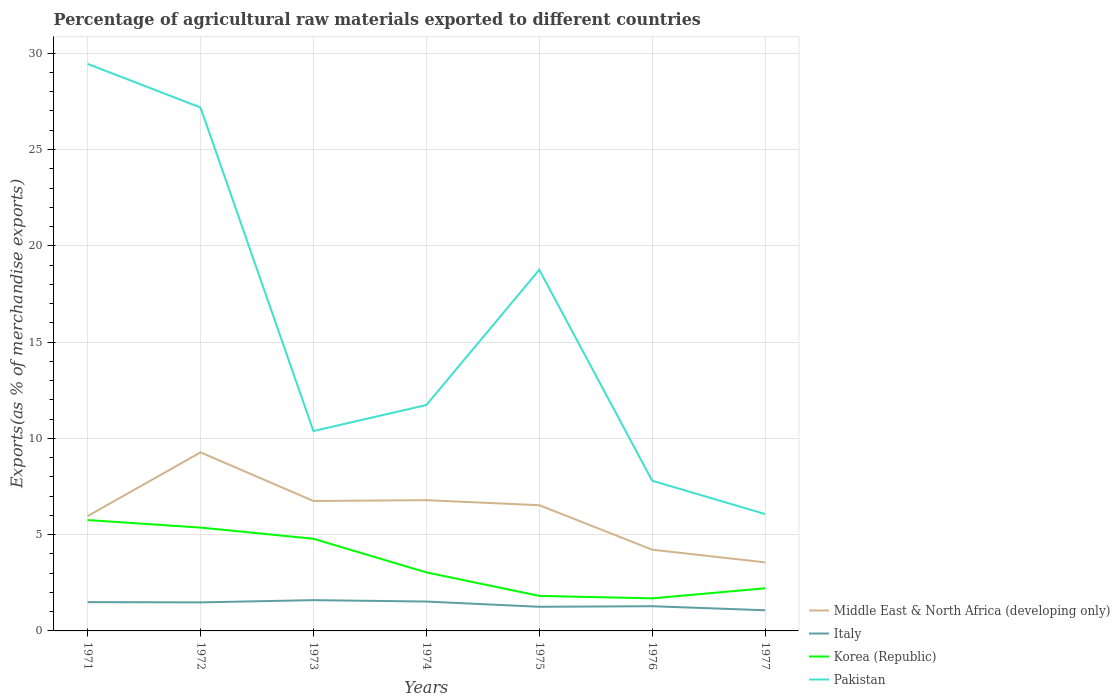How many different coloured lines are there?
Your response must be concise. 4. Is the number of lines equal to the number of legend labels?
Offer a terse response. Yes. Across all years, what is the maximum percentage of exports to different countries in Korea (Republic)?
Offer a very short reply. 1.69. In which year was the percentage of exports to different countries in Italy maximum?
Provide a succinct answer. 1977. What is the total percentage of exports to different countries in Pakistan in the graph?
Your answer should be very brief. 5.66. What is the difference between the highest and the second highest percentage of exports to different countries in Pakistan?
Your response must be concise. 23.38. What is the difference between the highest and the lowest percentage of exports to different countries in Italy?
Make the answer very short. 4. Is the percentage of exports to different countries in Italy strictly greater than the percentage of exports to different countries in Pakistan over the years?
Give a very brief answer. Yes. How many lines are there?
Keep it short and to the point. 4. Are the values on the major ticks of Y-axis written in scientific E-notation?
Make the answer very short. No. Does the graph contain any zero values?
Provide a short and direct response. No. Does the graph contain grids?
Your answer should be very brief. Yes. How are the legend labels stacked?
Your response must be concise. Vertical. What is the title of the graph?
Make the answer very short. Percentage of agricultural raw materials exported to different countries. Does "Chile" appear as one of the legend labels in the graph?
Provide a short and direct response. No. What is the label or title of the X-axis?
Your answer should be very brief. Years. What is the label or title of the Y-axis?
Your answer should be very brief. Exports(as % of merchandise exports). What is the Exports(as % of merchandise exports) of Middle East & North Africa (developing only) in 1971?
Your response must be concise. 5.96. What is the Exports(as % of merchandise exports) of Italy in 1971?
Offer a very short reply. 1.49. What is the Exports(as % of merchandise exports) of Korea (Republic) in 1971?
Provide a short and direct response. 5.76. What is the Exports(as % of merchandise exports) in Pakistan in 1971?
Provide a succinct answer. 29.45. What is the Exports(as % of merchandise exports) in Middle East & North Africa (developing only) in 1972?
Give a very brief answer. 9.27. What is the Exports(as % of merchandise exports) in Italy in 1972?
Your response must be concise. 1.48. What is the Exports(as % of merchandise exports) of Korea (Republic) in 1972?
Keep it short and to the point. 5.37. What is the Exports(as % of merchandise exports) of Pakistan in 1972?
Offer a very short reply. 27.18. What is the Exports(as % of merchandise exports) of Middle East & North Africa (developing only) in 1973?
Your answer should be compact. 6.75. What is the Exports(as % of merchandise exports) of Italy in 1973?
Provide a short and direct response. 1.6. What is the Exports(as % of merchandise exports) of Korea (Republic) in 1973?
Your response must be concise. 4.79. What is the Exports(as % of merchandise exports) in Pakistan in 1973?
Your response must be concise. 10.38. What is the Exports(as % of merchandise exports) of Middle East & North Africa (developing only) in 1974?
Make the answer very short. 6.79. What is the Exports(as % of merchandise exports) of Italy in 1974?
Offer a very short reply. 1.53. What is the Exports(as % of merchandise exports) in Korea (Republic) in 1974?
Provide a short and direct response. 3.04. What is the Exports(as % of merchandise exports) in Pakistan in 1974?
Keep it short and to the point. 11.73. What is the Exports(as % of merchandise exports) of Middle East & North Africa (developing only) in 1975?
Offer a terse response. 6.53. What is the Exports(as % of merchandise exports) of Italy in 1975?
Make the answer very short. 1.25. What is the Exports(as % of merchandise exports) of Korea (Republic) in 1975?
Keep it short and to the point. 1.82. What is the Exports(as % of merchandise exports) of Pakistan in 1975?
Offer a terse response. 18.75. What is the Exports(as % of merchandise exports) of Middle East & North Africa (developing only) in 1976?
Offer a terse response. 4.22. What is the Exports(as % of merchandise exports) of Italy in 1976?
Offer a terse response. 1.28. What is the Exports(as % of merchandise exports) in Korea (Republic) in 1976?
Give a very brief answer. 1.69. What is the Exports(as % of merchandise exports) of Pakistan in 1976?
Provide a succinct answer. 7.8. What is the Exports(as % of merchandise exports) of Middle East & North Africa (developing only) in 1977?
Offer a terse response. 3.56. What is the Exports(as % of merchandise exports) of Italy in 1977?
Offer a very short reply. 1.07. What is the Exports(as % of merchandise exports) in Korea (Republic) in 1977?
Offer a very short reply. 2.21. What is the Exports(as % of merchandise exports) in Pakistan in 1977?
Keep it short and to the point. 6.07. Across all years, what is the maximum Exports(as % of merchandise exports) in Middle East & North Africa (developing only)?
Provide a short and direct response. 9.27. Across all years, what is the maximum Exports(as % of merchandise exports) of Italy?
Make the answer very short. 1.6. Across all years, what is the maximum Exports(as % of merchandise exports) in Korea (Republic)?
Make the answer very short. 5.76. Across all years, what is the maximum Exports(as % of merchandise exports) in Pakistan?
Give a very brief answer. 29.45. Across all years, what is the minimum Exports(as % of merchandise exports) of Middle East & North Africa (developing only)?
Give a very brief answer. 3.56. Across all years, what is the minimum Exports(as % of merchandise exports) in Italy?
Provide a short and direct response. 1.07. Across all years, what is the minimum Exports(as % of merchandise exports) of Korea (Republic)?
Make the answer very short. 1.69. Across all years, what is the minimum Exports(as % of merchandise exports) in Pakistan?
Make the answer very short. 6.07. What is the total Exports(as % of merchandise exports) of Middle East & North Africa (developing only) in the graph?
Ensure brevity in your answer.  43.08. What is the total Exports(as % of merchandise exports) of Italy in the graph?
Provide a succinct answer. 9.71. What is the total Exports(as % of merchandise exports) of Korea (Republic) in the graph?
Your answer should be compact. 24.68. What is the total Exports(as % of merchandise exports) of Pakistan in the graph?
Give a very brief answer. 111.36. What is the difference between the Exports(as % of merchandise exports) in Middle East & North Africa (developing only) in 1971 and that in 1972?
Offer a terse response. -3.31. What is the difference between the Exports(as % of merchandise exports) of Italy in 1971 and that in 1972?
Your answer should be compact. 0.01. What is the difference between the Exports(as % of merchandise exports) in Korea (Republic) in 1971 and that in 1972?
Your answer should be compact. 0.39. What is the difference between the Exports(as % of merchandise exports) in Pakistan in 1971 and that in 1972?
Give a very brief answer. 2.26. What is the difference between the Exports(as % of merchandise exports) in Middle East & North Africa (developing only) in 1971 and that in 1973?
Offer a very short reply. -0.79. What is the difference between the Exports(as % of merchandise exports) of Italy in 1971 and that in 1973?
Your response must be concise. -0.1. What is the difference between the Exports(as % of merchandise exports) of Korea (Republic) in 1971 and that in 1973?
Provide a succinct answer. 0.97. What is the difference between the Exports(as % of merchandise exports) of Pakistan in 1971 and that in 1973?
Keep it short and to the point. 19.07. What is the difference between the Exports(as % of merchandise exports) in Middle East & North Africa (developing only) in 1971 and that in 1974?
Give a very brief answer. -0.83. What is the difference between the Exports(as % of merchandise exports) in Italy in 1971 and that in 1974?
Your response must be concise. -0.03. What is the difference between the Exports(as % of merchandise exports) in Korea (Republic) in 1971 and that in 1974?
Provide a short and direct response. 2.72. What is the difference between the Exports(as % of merchandise exports) of Pakistan in 1971 and that in 1974?
Your answer should be very brief. 17.72. What is the difference between the Exports(as % of merchandise exports) of Middle East & North Africa (developing only) in 1971 and that in 1975?
Give a very brief answer. -0.57. What is the difference between the Exports(as % of merchandise exports) in Italy in 1971 and that in 1975?
Your answer should be very brief. 0.24. What is the difference between the Exports(as % of merchandise exports) in Korea (Republic) in 1971 and that in 1975?
Give a very brief answer. 3.94. What is the difference between the Exports(as % of merchandise exports) in Pakistan in 1971 and that in 1975?
Offer a very short reply. 10.69. What is the difference between the Exports(as % of merchandise exports) of Middle East & North Africa (developing only) in 1971 and that in 1976?
Keep it short and to the point. 1.74. What is the difference between the Exports(as % of merchandise exports) in Italy in 1971 and that in 1976?
Provide a succinct answer. 0.21. What is the difference between the Exports(as % of merchandise exports) in Korea (Republic) in 1971 and that in 1976?
Your response must be concise. 4.07. What is the difference between the Exports(as % of merchandise exports) in Pakistan in 1971 and that in 1976?
Ensure brevity in your answer.  21.64. What is the difference between the Exports(as % of merchandise exports) in Middle East & North Africa (developing only) in 1971 and that in 1977?
Make the answer very short. 2.4. What is the difference between the Exports(as % of merchandise exports) in Italy in 1971 and that in 1977?
Keep it short and to the point. 0.42. What is the difference between the Exports(as % of merchandise exports) in Korea (Republic) in 1971 and that in 1977?
Your answer should be compact. 3.54. What is the difference between the Exports(as % of merchandise exports) in Pakistan in 1971 and that in 1977?
Offer a terse response. 23.38. What is the difference between the Exports(as % of merchandise exports) in Middle East & North Africa (developing only) in 1972 and that in 1973?
Offer a terse response. 2.52. What is the difference between the Exports(as % of merchandise exports) in Italy in 1972 and that in 1973?
Make the answer very short. -0.12. What is the difference between the Exports(as % of merchandise exports) in Korea (Republic) in 1972 and that in 1973?
Provide a short and direct response. 0.58. What is the difference between the Exports(as % of merchandise exports) in Pakistan in 1972 and that in 1973?
Provide a short and direct response. 16.8. What is the difference between the Exports(as % of merchandise exports) of Middle East & North Africa (developing only) in 1972 and that in 1974?
Your response must be concise. 2.48. What is the difference between the Exports(as % of merchandise exports) of Italy in 1972 and that in 1974?
Offer a very short reply. -0.04. What is the difference between the Exports(as % of merchandise exports) in Korea (Republic) in 1972 and that in 1974?
Keep it short and to the point. 2.33. What is the difference between the Exports(as % of merchandise exports) of Pakistan in 1972 and that in 1974?
Provide a succinct answer. 15.45. What is the difference between the Exports(as % of merchandise exports) in Middle East & North Africa (developing only) in 1972 and that in 1975?
Make the answer very short. 2.74. What is the difference between the Exports(as % of merchandise exports) of Italy in 1972 and that in 1975?
Provide a succinct answer. 0.23. What is the difference between the Exports(as % of merchandise exports) in Korea (Republic) in 1972 and that in 1975?
Give a very brief answer. 3.55. What is the difference between the Exports(as % of merchandise exports) in Pakistan in 1972 and that in 1975?
Make the answer very short. 8.43. What is the difference between the Exports(as % of merchandise exports) in Middle East & North Africa (developing only) in 1972 and that in 1976?
Ensure brevity in your answer.  5.05. What is the difference between the Exports(as % of merchandise exports) of Italy in 1972 and that in 1976?
Offer a terse response. 0.2. What is the difference between the Exports(as % of merchandise exports) of Korea (Republic) in 1972 and that in 1976?
Offer a very short reply. 3.67. What is the difference between the Exports(as % of merchandise exports) in Pakistan in 1972 and that in 1976?
Ensure brevity in your answer.  19.38. What is the difference between the Exports(as % of merchandise exports) of Middle East & North Africa (developing only) in 1972 and that in 1977?
Provide a succinct answer. 5.71. What is the difference between the Exports(as % of merchandise exports) of Italy in 1972 and that in 1977?
Your response must be concise. 0.41. What is the difference between the Exports(as % of merchandise exports) of Korea (Republic) in 1972 and that in 1977?
Offer a very short reply. 3.15. What is the difference between the Exports(as % of merchandise exports) in Pakistan in 1972 and that in 1977?
Your answer should be very brief. 21.11. What is the difference between the Exports(as % of merchandise exports) in Middle East & North Africa (developing only) in 1973 and that in 1974?
Offer a terse response. -0.04. What is the difference between the Exports(as % of merchandise exports) in Italy in 1973 and that in 1974?
Provide a short and direct response. 0.07. What is the difference between the Exports(as % of merchandise exports) in Korea (Republic) in 1973 and that in 1974?
Your answer should be very brief. 1.75. What is the difference between the Exports(as % of merchandise exports) of Pakistan in 1973 and that in 1974?
Give a very brief answer. -1.35. What is the difference between the Exports(as % of merchandise exports) of Middle East & North Africa (developing only) in 1973 and that in 1975?
Provide a short and direct response. 0.22. What is the difference between the Exports(as % of merchandise exports) of Italy in 1973 and that in 1975?
Keep it short and to the point. 0.34. What is the difference between the Exports(as % of merchandise exports) in Korea (Republic) in 1973 and that in 1975?
Make the answer very short. 2.97. What is the difference between the Exports(as % of merchandise exports) in Pakistan in 1973 and that in 1975?
Make the answer very short. -8.37. What is the difference between the Exports(as % of merchandise exports) in Middle East & North Africa (developing only) in 1973 and that in 1976?
Offer a very short reply. 2.53. What is the difference between the Exports(as % of merchandise exports) in Italy in 1973 and that in 1976?
Give a very brief answer. 0.32. What is the difference between the Exports(as % of merchandise exports) in Korea (Republic) in 1973 and that in 1976?
Keep it short and to the point. 3.09. What is the difference between the Exports(as % of merchandise exports) in Pakistan in 1973 and that in 1976?
Give a very brief answer. 2.58. What is the difference between the Exports(as % of merchandise exports) of Middle East & North Africa (developing only) in 1973 and that in 1977?
Give a very brief answer. 3.19. What is the difference between the Exports(as % of merchandise exports) in Italy in 1973 and that in 1977?
Your answer should be compact. 0.53. What is the difference between the Exports(as % of merchandise exports) of Korea (Republic) in 1973 and that in 1977?
Your answer should be very brief. 2.57. What is the difference between the Exports(as % of merchandise exports) of Pakistan in 1973 and that in 1977?
Give a very brief answer. 4.31. What is the difference between the Exports(as % of merchandise exports) of Middle East & North Africa (developing only) in 1974 and that in 1975?
Offer a very short reply. 0.26. What is the difference between the Exports(as % of merchandise exports) in Italy in 1974 and that in 1975?
Provide a succinct answer. 0.27. What is the difference between the Exports(as % of merchandise exports) in Korea (Republic) in 1974 and that in 1975?
Provide a succinct answer. 1.22. What is the difference between the Exports(as % of merchandise exports) in Pakistan in 1974 and that in 1975?
Your answer should be very brief. -7.02. What is the difference between the Exports(as % of merchandise exports) in Middle East & North Africa (developing only) in 1974 and that in 1976?
Ensure brevity in your answer.  2.57. What is the difference between the Exports(as % of merchandise exports) of Italy in 1974 and that in 1976?
Ensure brevity in your answer.  0.24. What is the difference between the Exports(as % of merchandise exports) in Korea (Republic) in 1974 and that in 1976?
Offer a terse response. 1.35. What is the difference between the Exports(as % of merchandise exports) in Pakistan in 1974 and that in 1976?
Make the answer very short. 3.93. What is the difference between the Exports(as % of merchandise exports) in Middle East & North Africa (developing only) in 1974 and that in 1977?
Give a very brief answer. 3.23. What is the difference between the Exports(as % of merchandise exports) in Italy in 1974 and that in 1977?
Your answer should be compact. 0.45. What is the difference between the Exports(as % of merchandise exports) in Korea (Republic) in 1974 and that in 1977?
Offer a very short reply. 0.83. What is the difference between the Exports(as % of merchandise exports) in Pakistan in 1974 and that in 1977?
Provide a short and direct response. 5.66. What is the difference between the Exports(as % of merchandise exports) in Middle East & North Africa (developing only) in 1975 and that in 1976?
Your answer should be very brief. 2.31. What is the difference between the Exports(as % of merchandise exports) in Italy in 1975 and that in 1976?
Keep it short and to the point. -0.03. What is the difference between the Exports(as % of merchandise exports) of Korea (Republic) in 1975 and that in 1976?
Your answer should be very brief. 0.13. What is the difference between the Exports(as % of merchandise exports) in Pakistan in 1975 and that in 1976?
Offer a terse response. 10.95. What is the difference between the Exports(as % of merchandise exports) in Middle East & North Africa (developing only) in 1975 and that in 1977?
Ensure brevity in your answer.  2.97. What is the difference between the Exports(as % of merchandise exports) in Italy in 1975 and that in 1977?
Keep it short and to the point. 0.18. What is the difference between the Exports(as % of merchandise exports) of Korea (Republic) in 1975 and that in 1977?
Your answer should be very brief. -0.4. What is the difference between the Exports(as % of merchandise exports) of Pakistan in 1975 and that in 1977?
Your answer should be compact. 12.68. What is the difference between the Exports(as % of merchandise exports) in Middle East & North Africa (developing only) in 1976 and that in 1977?
Ensure brevity in your answer.  0.66. What is the difference between the Exports(as % of merchandise exports) in Italy in 1976 and that in 1977?
Offer a very short reply. 0.21. What is the difference between the Exports(as % of merchandise exports) of Korea (Republic) in 1976 and that in 1977?
Your response must be concise. -0.52. What is the difference between the Exports(as % of merchandise exports) in Pakistan in 1976 and that in 1977?
Ensure brevity in your answer.  1.73. What is the difference between the Exports(as % of merchandise exports) of Middle East & North Africa (developing only) in 1971 and the Exports(as % of merchandise exports) of Italy in 1972?
Your answer should be compact. 4.48. What is the difference between the Exports(as % of merchandise exports) of Middle East & North Africa (developing only) in 1971 and the Exports(as % of merchandise exports) of Korea (Republic) in 1972?
Give a very brief answer. 0.59. What is the difference between the Exports(as % of merchandise exports) in Middle East & North Africa (developing only) in 1971 and the Exports(as % of merchandise exports) in Pakistan in 1972?
Your answer should be very brief. -21.22. What is the difference between the Exports(as % of merchandise exports) of Italy in 1971 and the Exports(as % of merchandise exports) of Korea (Republic) in 1972?
Offer a very short reply. -3.87. What is the difference between the Exports(as % of merchandise exports) of Italy in 1971 and the Exports(as % of merchandise exports) of Pakistan in 1972?
Offer a terse response. -25.69. What is the difference between the Exports(as % of merchandise exports) in Korea (Republic) in 1971 and the Exports(as % of merchandise exports) in Pakistan in 1972?
Offer a very short reply. -21.42. What is the difference between the Exports(as % of merchandise exports) of Middle East & North Africa (developing only) in 1971 and the Exports(as % of merchandise exports) of Italy in 1973?
Your answer should be very brief. 4.36. What is the difference between the Exports(as % of merchandise exports) in Middle East & North Africa (developing only) in 1971 and the Exports(as % of merchandise exports) in Korea (Republic) in 1973?
Ensure brevity in your answer.  1.17. What is the difference between the Exports(as % of merchandise exports) in Middle East & North Africa (developing only) in 1971 and the Exports(as % of merchandise exports) in Pakistan in 1973?
Keep it short and to the point. -4.42. What is the difference between the Exports(as % of merchandise exports) in Italy in 1971 and the Exports(as % of merchandise exports) in Korea (Republic) in 1973?
Provide a short and direct response. -3.29. What is the difference between the Exports(as % of merchandise exports) of Italy in 1971 and the Exports(as % of merchandise exports) of Pakistan in 1973?
Offer a terse response. -8.88. What is the difference between the Exports(as % of merchandise exports) of Korea (Republic) in 1971 and the Exports(as % of merchandise exports) of Pakistan in 1973?
Provide a short and direct response. -4.62. What is the difference between the Exports(as % of merchandise exports) of Middle East & North Africa (developing only) in 1971 and the Exports(as % of merchandise exports) of Italy in 1974?
Provide a succinct answer. 4.43. What is the difference between the Exports(as % of merchandise exports) in Middle East & North Africa (developing only) in 1971 and the Exports(as % of merchandise exports) in Korea (Republic) in 1974?
Provide a short and direct response. 2.92. What is the difference between the Exports(as % of merchandise exports) of Middle East & North Africa (developing only) in 1971 and the Exports(as % of merchandise exports) of Pakistan in 1974?
Keep it short and to the point. -5.77. What is the difference between the Exports(as % of merchandise exports) of Italy in 1971 and the Exports(as % of merchandise exports) of Korea (Republic) in 1974?
Your answer should be compact. -1.54. What is the difference between the Exports(as % of merchandise exports) in Italy in 1971 and the Exports(as % of merchandise exports) in Pakistan in 1974?
Your answer should be compact. -10.23. What is the difference between the Exports(as % of merchandise exports) of Korea (Republic) in 1971 and the Exports(as % of merchandise exports) of Pakistan in 1974?
Make the answer very short. -5.97. What is the difference between the Exports(as % of merchandise exports) in Middle East & North Africa (developing only) in 1971 and the Exports(as % of merchandise exports) in Italy in 1975?
Provide a succinct answer. 4.71. What is the difference between the Exports(as % of merchandise exports) of Middle East & North Africa (developing only) in 1971 and the Exports(as % of merchandise exports) of Korea (Republic) in 1975?
Provide a succinct answer. 4.14. What is the difference between the Exports(as % of merchandise exports) in Middle East & North Africa (developing only) in 1971 and the Exports(as % of merchandise exports) in Pakistan in 1975?
Make the answer very short. -12.79. What is the difference between the Exports(as % of merchandise exports) of Italy in 1971 and the Exports(as % of merchandise exports) of Korea (Republic) in 1975?
Provide a succinct answer. -0.32. What is the difference between the Exports(as % of merchandise exports) in Italy in 1971 and the Exports(as % of merchandise exports) in Pakistan in 1975?
Give a very brief answer. -17.26. What is the difference between the Exports(as % of merchandise exports) of Korea (Republic) in 1971 and the Exports(as % of merchandise exports) of Pakistan in 1975?
Provide a succinct answer. -12.99. What is the difference between the Exports(as % of merchandise exports) in Middle East & North Africa (developing only) in 1971 and the Exports(as % of merchandise exports) in Italy in 1976?
Your response must be concise. 4.68. What is the difference between the Exports(as % of merchandise exports) in Middle East & North Africa (developing only) in 1971 and the Exports(as % of merchandise exports) in Korea (Republic) in 1976?
Make the answer very short. 4.27. What is the difference between the Exports(as % of merchandise exports) of Middle East & North Africa (developing only) in 1971 and the Exports(as % of merchandise exports) of Pakistan in 1976?
Give a very brief answer. -1.84. What is the difference between the Exports(as % of merchandise exports) in Italy in 1971 and the Exports(as % of merchandise exports) in Korea (Republic) in 1976?
Provide a short and direct response. -0.2. What is the difference between the Exports(as % of merchandise exports) in Italy in 1971 and the Exports(as % of merchandise exports) in Pakistan in 1976?
Provide a succinct answer. -6.31. What is the difference between the Exports(as % of merchandise exports) in Korea (Republic) in 1971 and the Exports(as % of merchandise exports) in Pakistan in 1976?
Your answer should be compact. -2.04. What is the difference between the Exports(as % of merchandise exports) of Middle East & North Africa (developing only) in 1971 and the Exports(as % of merchandise exports) of Italy in 1977?
Your answer should be compact. 4.89. What is the difference between the Exports(as % of merchandise exports) in Middle East & North Africa (developing only) in 1971 and the Exports(as % of merchandise exports) in Korea (Republic) in 1977?
Provide a short and direct response. 3.75. What is the difference between the Exports(as % of merchandise exports) of Middle East & North Africa (developing only) in 1971 and the Exports(as % of merchandise exports) of Pakistan in 1977?
Ensure brevity in your answer.  -0.11. What is the difference between the Exports(as % of merchandise exports) of Italy in 1971 and the Exports(as % of merchandise exports) of Korea (Republic) in 1977?
Offer a very short reply. -0.72. What is the difference between the Exports(as % of merchandise exports) in Italy in 1971 and the Exports(as % of merchandise exports) in Pakistan in 1977?
Your answer should be compact. -4.57. What is the difference between the Exports(as % of merchandise exports) in Korea (Republic) in 1971 and the Exports(as % of merchandise exports) in Pakistan in 1977?
Your answer should be compact. -0.31. What is the difference between the Exports(as % of merchandise exports) in Middle East & North Africa (developing only) in 1972 and the Exports(as % of merchandise exports) in Italy in 1973?
Make the answer very short. 7.67. What is the difference between the Exports(as % of merchandise exports) in Middle East & North Africa (developing only) in 1972 and the Exports(as % of merchandise exports) in Korea (Republic) in 1973?
Your answer should be compact. 4.49. What is the difference between the Exports(as % of merchandise exports) in Middle East & North Africa (developing only) in 1972 and the Exports(as % of merchandise exports) in Pakistan in 1973?
Offer a terse response. -1.11. What is the difference between the Exports(as % of merchandise exports) in Italy in 1972 and the Exports(as % of merchandise exports) in Korea (Republic) in 1973?
Your response must be concise. -3.3. What is the difference between the Exports(as % of merchandise exports) of Italy in 1972 and the Exports(as % of merchandise exports) of Pakistan in 1973?
Your response must be concise. -8.9. What is the difference between the Exports(as % of merchandise exports) of Korea (Republic) in 1972 and the Exports(as % of merchandise exports) of Pakistan in 1973?
Provide a short and direct response. -5.01. What is the difference between the Exports(as % of merchandise exports) in Middle East & North Africa (developing only) in 1972 and the Exports(as % of merchandise exports) in Italy in 1974?
Your answer should be very brief. 7.75. What is the difference between the Exports(as % of merchandise exports) of Middle East & North Africa (developing only) in 1972 and the Exports(as % of merchandise exports) of Korea (Republic) in 1974?
Keep it short and to the point. 6.23. What is the difference between the Exports(as % of merchandise exports) in Middle East & North Africa (developing only) in 1972 and the Exports(as % of merchandise exports) in Pakistan in 1974?
Make the answer very short. -2.46. What is the difference between the Exports(as % of merchandise exports) in Italy in 1972 and the Exports(as % of merchandise exports) in Korea (Republic) in 1974?
Give a very brief answer. -1.56. What is the difference between the Exports(as % of merchandise exports) of Italy in 1972 and the Exports(as % of merchandise exports) of Pakistan in 1974?
Your answer should be compact. -10.25. What is the difference between the Exports(as % of merchandise exports) in Korea (Republic) in 1972 and the Exports(as % of merchandise exports) in Pakistan in 1974?
Offer a very short reply. -6.36. What is the difference between the Exports(as % of merchandise exports) in Middle East & North Africa (developing only) in 1972 and the Exports(as % of merchandise exports) in Italy in 1975?
Ensure brevity in your answer.  8.02. What is the difference between the Exports(as % of merchandise exports) of Middle East & North Africa (developing only) in 1972 and the Exports(as % of merchandise exports) of Korea (Republic) in 1975?
Offer a very short reply. 7.45. What is the difference between the Exports(as % of merchandise exports) of Middle East & North Africa (developing only) in 1972 and the Exports(as % of merchandise exports) of Pakistan in 1975?
Provide a succinct answer. -9.48. What is the difference between the Exports(as % of merchandise exports) in Italy in 1972 and the Exports(as % of merchandise exports) in Korea (Republic) in 1975?
Provide a succinct answer. -0.34. What is the difference between the Exports(as % of merchandise exports) of Italy in 1972 and the Exports(as % of merchandise exports) of Pakistan in 1975?
Provide a short and direct response. -17.27. What is the difference between the Exports(as % of merchandise exports) of Korea (Republic) in 1972 and the Exports(as % of merchandise exports) of Pakistan in 1975?
Your response must be concise. -13.39. What is the difference between the Exports(as % of merchandise exports) in Middle East & North Africa (developing only) in 1972 and the Exports(as % of merchandise exports) in Italy in 1976?
Provide a succinct answer. 7.99. What is the difference between the Exports(as % of merchandise exports) in Middle East & North Africa (developing only) in 1972 and the Exports(as % of merchandise exports) in Korea (Republic) in 1976?
Make the answer very short. 7.58. What is the difference between the Exports(as % of merchandise exports) of Middle East & North Africa (developing only) in 1972 and the Exports(as % of merchandise exports) of Pakistan in 1976?
Your answer should be very brief. 1.47. What is the difference between the Exports(as % of merchandise exports) of Italy in 1972 and the Exports(as % of merchandise exports) of Korea (Republic) in 1976?
Provide a succinct answer. -0.21. What is the difference between the Exports(as % of merchandise exports) of Italy in 1972 and the Exports(as % of merchandise exports) of Pakistan in 1976?
Give a very brief answer. -6.32. What is the difference between the Exports(as % of merchandise exports) in Korea (Republic) in 1972 and the Exports(as % of merchandise exports) in Pakistan in 1976?
Provide a succinct answer. -2.43. What is the difference between the Exports(as % of merchandise exports) in Middle East & North Africa (developing only) in 1972 and the Exports(as % of merchandise exports) in Italy in 1977?
Make the answer very short. 8.2. What is the difference between the Exports(as % of merchandise exports) in Middle East & North Africa (developing only) in 1972 and the Exports(as % of merchandise exports) in Korea (Republic) in 1977?
Ensure brevity in your answer.  7.06. What is the difference between the Exports(as % of merchandise exports) of Middle East & North Africa (developing only) in 1972 and the Exports(as % of merchandise exports) of Pakistan in 1977?
Ensure brevity in your answer.  3.2. What is the difference between the Exports(as % of merchandise exports) of Italy in 1972 and the Exports(as % of merchandise exports) of Korea (Republic) in 1977?
Give a very brief answer. -0.73. What is the difference between the Exports(as % of merchandise exports) of Italy in 1972 and the Exports(as % of merchandise exports) of Pakistan in 1977?
Keep it short and to the point. -4.59. What is the difference between the Exports(as % of merchandise exports) of Korea (Republic) in 1972 and the Exports(as % of merchandise exports) of Pakistan in 1977?
Your response must be concise. -0.7. What is the difference between the Exports(as % of merchandise exports) in Middle East & North Africa (developing only) in 1973 and the Exports(as % of merchandise exports) in Italy in 1974?
Offer a terse response. 5.22. What is the difference between the Exports(as % of merchandise exports) in Middle East & North Africa (developing only) in 1973 and the Exports(as % of merchandise exports) in Korea (Republic) in 1974?
Make the answer very short. 3.71. What is the difference between the Exports(as % of merchandise exports) in Middle East & North Africa (developing only) in 1973 and the Exports(as % of merchandise exports) in Pakistan in 1974?
Give a very brief answer. -4.98. What is the difference between the Exports(as % of merchandise exports) of Italy in 1973 and the Exports(as % of merchandise exports) of Korea (Republic) in 1974?
Make the answer very short. -1.44. What is the difference between the Exports(as % of merchandise exports) in Italy in 1973 and the Exports(as % of merchandise exports) in Pakistan in 1974?
Provide a succinct answer. -10.13. What is the difference between the Exports(as % of merchandise exports) of Korea (Republic) in 1973 and the Exports(as % of merchandise exports) of Pakistan in 1974?
Offer a very short reply. -6.94. What is the difference between the Exports(as % of merchandise exports) in Middle East & North Africa (developing only) in 1973 and the Exports(as % of merchandise exports) in Italy in 1975?
Provide a short and direct response. 5.49. What is the difference between the Exports(as % of merchandise exports) of Middle East & North Africa (developing only) in 1973 and the Exports(as % of merchandise exports) of Korea (Republic) in 1975?
Your response must be concise. 4.93. What is the difference between the Exports(as % of merchandise exports) of Middle East & North Africa (developing only) in 1973 and the Exports(as % of merchandise exports) of Pakistan in 1975?
Keep it short and to the point. -12. What is the difference between the Exports(as % of merchandise exports) in Italy in 1973 and the Exports(as % of merchandise exports) in Korea (Republic) in 1975?
Give a very brief answer. -0.22. What is the difference between the Exports(as % of merchandise exports) of Italy in 1973 and the Exports(as % of merchandise exports) of Pakistan in 1975?
Provide a short and direct response. -17.15. What is the difference between the Exports(as % of merchandise exports) in Korea (Republic) in 1973 and the Exports(as % of merchandise exports) in Pakistan in 1975?
Keep it short and to the point. -13.97. What is the difference between the Exports(as % of merchandise exports) of Middle East & North Africa (developing only) in 1973 and the Exports(as % of merchandise exports) of Italy in 1976?
Your answer should be compact. 5.46. What is the difference between the Exports(as % of merchandise exports) in Middle East & North Africa (developing only) in 1973 and the Exports(as % of merchandise exports) in Korea (Republic) in 1976?
Provide a short and direct response. 5.06. What is the difference between the Exports(as % of merchandise exports) in Middle East & North Africa (developing only) in 1973 and the Exports(as % of merchandise exports) in Pakistan in 1976?
Make the answer very short. -1.05. What is the difference between the Exports(as % of merchandise exports) of Italy in 1973 and the Exports(as % of merchandise exports) of Korea (Republic) in 1976?
Keep it short and to the point. -0.09. What is the difference between the Exports(as % of merchandise exports) of Italy in 1973 and the Exports(as % of merchandise exports) of Pakistan in 1976?
Offer a terse response. -6.2. What is the difference between the Exports(as % of merchandise exports) of Korea (Republic) in 1973 and the Exports(as % of merchandise exports) of Pakistan in 1976?
Your response must be concise. -3.01. What is the difference between the Exports(as % of merchandise exports) of Middle East & North Africa (developing only) in 1973 and the Exports(as % of merchandise exports) of Italy in 1977?
Give a very brief answer. 5.67. What is the difference between the Exports(as % of merchandise exports) of Middle East & North Africa (developing only) in 1973 and the Exports(as % of merchandise exports) of Korea (Republic) in 1977?
Your answer should be compact. 4.53. What is the difference between the Exports(as % of merchandise exports) in Middle East & North Africa (developing only) in 1973 and the Exports(as % of merchandise exports) in Pakistan in 1977?
Make the answer very short. 0.68. What is the difference between the Exports(as % of merchandise exports) of Italy in 1973 and the Exports(as % of merchandise exports) of Korea (Republic) in 1977?
Ensure brevity in your answer.  -0.62. What is the difference between the Exports(as % of merchandise exports) in Italy in 1973 and the Exports(as % of merchandise exports) in Pakistan in 1977?
Your response must be concise. -4.47. What is the difference between the Exports(as % of merchandise exports) of Korea (Republic) in 1973 and the Exports(as % of merchandise exports) of Pakistan in 1977?
Offer a terse response. -1.28. What is the difference between the Exports(as % of merchandise exports) of Middle East & North Africa (developing only) in 1974 and the Exports(as % of merchandise exports) of Italy in 1975?
Offer a terse response. 5.54. What is the difference between the Exports(as % of merchandise exports) of Middle East & North Africa (developing only) in 1974 and the Exports(as % of merchandise exports) of Korea (Republic) in 1975?
Offer a terse response. 4.97. What is the difference between the Exports(as % of merchandise exports) in Middle East & North Africa (developing only) in 1974 and the Exports(as % of merchandise exports) in Pakistan in 1975?
Keep it short and to the point. -11.96. What is the difference between the Exports(as % of merchandise exports) in Italy in 1974 and the Exports(as % of merchandise exports) in Korea (Republic) in 1975?
Provide a succinct answer. -0.29. What is the difference between the Exports(as % of merchandise exports) of Italy in 1974 and the Exports(as % of merchandise exports) of Pakistan in 1975?
Your response must be concise. -17.23. What is the difference between the Exports(as % of merchandise exports) of Korea (Republic) in 1974 and the Exports(as % of merchandise exports) of Pakistan in 1975?
Offer a very short reply. -15.71. What is the difference between the Exports(as % of merchandise exports) in Middle East & North Africa (developing only) in 1974 and the Exports(as % of merchandise exports) in Italy in 1976?
Give a very brief answer. 5.51. What is the difference between the Exports(as % of merchandise exports) in Middle East & North Africa (developing only) in 1974 and the Exports(as % of merchandise exports) in Korea (Republic) in 1976?
Your answer should be very brief. 5.1. What is the difference between the Exports(as % of merchandise exports) in Middle East & North Africa (developing only) in 1974 and the Exports(as % of merchandise exports) in Pakistan in 1976?
Provide a succinct answer. -1.01. What is the difference between the Exports(as % of merchandise exports) in Italy in 1974 and the Exports(as % of merchandise exports) in Korea (Republic) in 1976?
Provide a succinct answer. -0.17. What is the difference between the Exports(as % of merchandise exports) of Italy in 1974 and the Exports(as % of merchandise exports) of Pakistan in 1976?
Provide a short and direct response. -6.27. What is the difference between the Exports(as % of merchandise exports) in Korea (Republic) in 1974 and the Exports(as % of merchandise exports) in Pakistan in 1976?
Offer a terse response. -4.76. What is the difference between the Exports(as % of merchandise exports) in Middle East & North Africa (developing only) in 1974 and the Exports(as % of merchandise exports) in Italy in 1977?
Give a very brief answer. 5.72. What is the difference between the Exports(as % of merchandise exports) of Middle East & North Africa (developing only) in 1974 and the Exports(as % of merchandise exports) of Korea (Republic) in 1977?
Your answer should be very brief. 4.58. What is the difference between the Exports(as % of merchandise exports) in Middle East & North Africa (developing only) in 1974 and the Exports(as % of merchandise exports) in Pakistan in 1977?
Your answer should be very brief. 0.72. What is the difference between the Exports(as % of merchandise exports) in Italy in 1974 and the Exports(as % of merchandise exports) in Korea (Republic) in 1977?
Ensure brevity in your answer.  -0.69. What is the difference between the Exports(as % of merchandise exports) in Italy in 1974 and the Exports(as % of merchandise exports) in Pakistan in 1977?
Your response must be concise. -4.54. What is the difference between the Exports(as % of merchandise exports) of Korea (Republic) in 1974 and the Exports(as % of merchandise exports) of Pakistan in 1977?
Offer a terse response. -3.03. What is the difference between the Exports(as % of merchandise exports) in Middle East & North Africa (developing only) in 1975 and the Exports(as % of merchandise exports) in Italy in 1976?
Your response must be concise. 5.25. What is the difference between the Exports(as % of merchandise exports) in Middle East & North Africa (developing only) in 1975 and the Exports(as % of merchandise exports) in Korea (Republic) in 1976?
Your response must be concise. 4.84. What is the difference between the Exports(as % of merchandise exports) in Middle East & North Africa (developing only) in 1975 and the Exports(as % of merchandise exports) in Pakistan in 1976?
Ensure brevity in your answer.  -1.27. What is the difference between the Exports(as % of merchandise exports) of Italy in 1975 and the Exports(as % of merchandise exports) of Korea (Republic) in 1976?
Ensure brevity in your answer.  -0.44. What is the difference between the Exports(as % of merchandise exports) of Italy in 1975 and the Exports(as % of merchandise exports) of Pakistan in 1976?
Provide a short and direct response. -6.55. What is the difference between the Exports(as % of merchandise exports) in Korea (Republic) in 1975 and the Exports(as % of merchandise exports) in Pakistan in 1976?
Provide a short and direct response. -5.98. What is the difference between the Exports(as % of merchandise exports) of Middle East & North Africa (developing only) in 1975 and the Exports(as % of merchandise exports) of Italy in 1977?
Your response must be concise. 5.46. What is the difference between the Exports(as % of merchandise exports) in Middle East & North Africa (developing only) in 1975 and the Exports(as % of merchandise exports) in Korea (Republic) in 1977?
Your answer should be very brief. 4.31. What is the difference between the Exports(as % of merchandise exports) of Middle East & North Africa (developing only) in 1975 and the Exports(as % of merchandise exports) of Pakistan in 1977?
Your response must be concise. 0.46. What is the difference between the Exports(as % of merchandise exports) in Italy in 1975 and the Exports(as % of merchandise exports) in Korea (Republic) in 1977?
Ensure brevity in your answer.  -0.96. What is the difference between the Exports(as % of merchandise exports) in Italy in 1975 and the Exports(as % of merchandise exports) in Pakistan in 1977?
Keep it short and to the point. -4.82. What is the difference between the Exports(as % of merchandise exports) of Korea (Republic) in 1975 and the Exports(as % of merchandise exports) of Pakistan in 1977?
Provide a short and direct response. -4.25. What is the difference between the Exports(as % of merchandise exports) of Middle East & North Africa (developing only) in 1976 and the Exports(as % of merchandise exports) of Italy in 1977?
Give a very brief answer. 3.15. What is the difference between the Exports(as % of merchandise exports) of Middle East & North Africa (developing only) in 1976 and the Exports(as % of merchandise exports) of Korea (Republic) in 1977?
Give a very brief answer. 2. What is the difference between the Exports(as % of merchandise exports) in Middle East & North Africa (developing only) in 1976 and the Exports(as % of merchandise exports) in Pakistan in 1977?
Your response must be concise. -1.85. What is the difference between the Exports(as % of merchandise exports) in Italy in 1976 and the Exports(as % of merchandise exports) in Korea (Republic) in 1977?
Offer a very short reply. -0.93. What is the difference between the Exports(as % of merchandise exports) in Italy in 1976 and the Exports(as % of merchandise exports) in Pakistan in 1977?
Ensure brevity in your answer.  -4.79. What is the difference between the Exports(as % of merchandise exports) in Korea (Republic) in 1976 and the Exports(as % of merchandise exports) in Pakistan in 1977?
Provide a short and direct response. -4.38. What is the average Exports(as % of merchandise exports) of Middle East & North Africa (developing only) per year?
Your answer should be compact. 6.15. What is the average Exports(as % of merchandise exports) in Italy per year?
Your response must be concise. 1.39. What is the average Exports(as % of merchandise exports) in Korea (Republic) per year?
Your answer should be very brief. 3.52. What is the average Exports(as % of merchandise exports) of Pakistan per year?
Your response must be concise. 15.91. In the year 1971, what is the difference between the Exports(as % of merchandise exports) in Middle East & North Africa (developing only) and Exports(as % of merchandise exports) in Italy?
Provide a short and direct response. 4.47. In the year 1971, what is the difference between the Exports(as % of merchandise exports) in Middle East & North Africa (developing only) and Exports(as % of merchandise exports) in Korea (Republic)?
Provide a succinct answer. 0.2. In the year 1971, what is the difference between the Exports(as % of merchandise exports) of Middle East & North Africa (developing only) and Exports(as % of merchandise exports) of Pakistan?
Your answer should be very brief. -23.48. In the year 1971, what is the difference between the Exports(as % of merchandise exports) of Italy and Exports(as % of merchandise exports) of Korea (Republic)?
Ensure brevity in your answer.  -4.26. In the year 1971, what is the difference between the Exports(as % of merchandise exports) in Italy and Exports(as % of merchandise exports) in Pakistan?
Give a very brief answer. -27.95. In the year 1971, what is the difference between the Exports(as % of merchandise exports) of Korea (Republic) and Exports(as % of merchandise exports) of Pakistan?
Give a very brief answer. -23.69. In the year 1972, what is the difference between the Exports(as % of merchandise exports) in Middle East & North Africa (developing only) and Exports(as % of merchandise exports) in Italy?
Offer a very short reply. 7.79. In the year 1972, what is the difference between the Exports(as % of merchandise exports) in Middle East & North Africa (developing only) and Exports(as % of merchandise exports) in Korea (Republic)?
Offer a very short reply. 3.91. In the year 1972, what is the difference between the Exports(as % of merchandise exports) in Middle East & North Africa (developing only) and Exports(as % of merchandise exports) in Pakistan?
Provide a short and direct response. -17.91. In the year 1972, what is the difference between the Exports(as % of merchandise exports) in Italy and Exports(as % of merchandise exports) in Korea (Republic)?
Your answer should be compact. -3.88. In the year 1972, what is the difference between the Exports(as % of merchandise exports) in Italy and Exports(as % of merchandise exports) in Pakistan?
Ensure brevity in your answer.  -25.7. In the year 1972, what is the difference between the Exports(as % of merchandise exports) in Korea (Republic) and Exports(as % of merchandise exports) in Pakistan?
Ensure brevity in your answer.  -21.81. In the year 1973, what is the difference between the Exports(as % of merchandise exports) of Middle East & North Africa (developing only) and Exports(as % of merchandise exports) of Italy?
Your answer should be very brief. 5.15. In the year 1973, what is the difference between the Exports(as % of merchandise exports) of Middle East & North Africa (developing only) and Exports(as % of merchandise exports) of Korea (Republic)?
Offer a very short reply. 1.96. In the year 1973, what is the difference between the Exports(as % of merchandise exports) in Middle East & North Africa (developing only) and Exports(as % of merchandise exports) in Pakistan?
Provide a short and direct response. -3.63. In the year 1973, what is the difference between the Exports(as % of merchandise exports) in Italy and Exports(as % of merchandise exports) in Korea (Republic)?
Provide a succinct answer. -3.19. In the year 1973, what is the difference between the Exports(as % of merchandise exports) of Italy and Exports(as % of merchandise exports) of Pakistan?
Offer a very short reply. -8.78. In the year 1973, what is the difference between the Exports(as % of merchandise exports) in Korea (Republic) and Exports(as % of merchandise exports) in Pakistan?
Keep it short and to the point. -5.59. In the year 1974, what is the difference between the Exports(as % of merchandise exports) in Middle East & North Africa (developing only) and Exports(as % of merchandise exports) in Italy?
Make the answer very short. 5.26. In the year 1974, what is the difference between the Exports(as % of merchandise exports) in Middle East & North Africa (developing only) and Exports(as % of merchandise exports) in Korea (Republic)?
Offer a terse response. 3.75. In the year 1974, what is the difference between the Exports(as % of merchandise exports) of Middle East & North Africa (developing only) and Exports(as % of merchandise exports) of Pakistan?
Your response must be concise. -4.94. In the year 1974, what is the difference between the Exports(as % of merchandise exports) of Italy and Exports(as % of merchandise exports) of Korea (Republic)?
Provide a succinct answer. -1.51. In the year 1974, what is the difference between the Exports(as % of merchandise exports) of Italy and Exports(as % of merchandise exports) of Pakistan?
Offer a terse response. -10.2. In the year 1974, what is the difference between the Exports(as % of merchandise exports) of Korea (Republic) and Exports(as % of merchandise exports) of Pakistan?
Ensure brevity in your answer.  -8.69. In the year 1975, what is the difference between the Exports(as % of merchandise exports) in Middle East & North Africa (developing only) and Exports(as % of merchandise exports) in Italy?
Provide a short and direct response. 5.28. In the year 1975, what is the difference between the Exports(as % of merchandise exports) in Middle East & North Africa (developing only) and Exports(as % of merchandise exports) in Korea (Republic)?
Your answer should be compact. 4.71. In the year 1975, what is the difference between the Exports(as % of merchandise exports) in Middle East & North Africa (developing only) and Exports(as % of merchandise exports) in Pakistan?
Ensure brevity in your answer.  -12.22. In the year 1975, what is the difference between the Exports(as % of merchandise exports) of Italy and Exports(as % of merchandise exports) of Korea (Republic)?
Make the answer very short. -0.57. In the year 1975, what is the difference between the Exports(as % of merchandise exports) in Italy and Exports(as % of merchandise exports) in Pakistan?
Offer a very short reply. -17.5. In the year 1975, what is the difference between the Exports(as % of merchandise exports) of Korea (Republic) and Exports(as % of merchandise exports) of Pakistan?
Your answer should be very brief. -16.93. In the year 1976, what is the difference between the Exports(as % of merchandise exports) of Middle East & North Africa (developing only) and Exports(as % of merchandise exports) of Italy?
Keep it short and to the point. 2.94. In the year 1976, what is the difference between the Exports(as % of merchandise exports) of Middle East & North Africa (developing only) and Exports(as % of merchandise exports) of Korea (Republic)?
Your answer should be compact. 2.53. In the year 1976, what is the difference between the Exports(as % of merchandise exports) in Middle East & North Africa (developing only) and Exports(as % of merchandise exports) in Pakistan?
Your response must be concise. -3.58. In the year 1976, what is the difference between the Exports(as % of merchandise exports) of Italy and Exports(as % of merchandise exports) of Korea (Republic)?
Your response must be concise. -0.41. In the year 1976, what is the difference between the Exports(as % of merchandise exports) in Italy and Exports(as % of merchandise exports) in Pakistan?
Your answer should be very brief. -6.52. In the year 1976, what is the difference between the Exports(as % of merchandise exports) of Korea (Republic) and Exports(as % of merchandise exports) of Pakistan?
Your response must be concise. -6.11. In the year 1977, what is the difference between the Exports(as % of merchandise exports) of Middle East & North Africa (developing only) and Exports(as % of merchandise exports) of Italy?
Your answer should be compact. 2.49. In the year 1977, what is the difference between the Exports(as % of merchandise exports) of Middle East & North Africa (developing only) and Exports(as % of merchandise exports) of Korea (Republic)?
Your response must be concise. 1.35. In the year 1977, what is the difference between the Exports(as % of merchandise exports) of Middle East & North Africa (developing only) and Exports(as % of merchandise exports) of Pakistan?
Offer a very short reply. -2.51. In the year 1977, what is the difference between the Exports(as % of merchandise exports) in Italy and Exports(as % of merchandise exports) in Korea (Republic)?
Make the answer very short. -1.14. In the year 1977, what is the difference between the Exports(as % of merchandise exports) in Italy and Exports(as % of merchandise exports) in Pakistan?
Your response must be concise. -5. In the year 1977, what is the difference between the Exports(as % of merchandise exports) in Korea (Republic) and Exports(as % of merchandise exports) in Pakistan?
Provide a short and direct response. -3.85. What is the ratio of the Exports(as % of merchandise exports) in Middle East & North Africa (developing only) in 1971 to that in 1972?
Make the answer very short. 0.64. What is the ratio of the Exports(as % of merchandise exports) of Italy in 1971 to that in 1972?
Offer a terse response. 1.01. What is the ratio of the Exports(as % of merchandise exports) in Korea (Republic) in 1971 to that in 1972?
Your response must be concise. 1.07. What is the ratio of the Exports(as % of merchandise exports) of Pakistan in 1971 to that in 1972?
Ensure brevity in your answer.  1.08. What is the ratio of the Exports(as % of merchandise exports) of Middle East & North Africa (developing only) in 1971 to that in 1973?
Offer a very short reply. 0.88. What is the ratio of the Exports(as % of merchandise exports) of Italy in 1971 to that in 1973?
Give a very brief answer. 0.94. What is the ratio of the Exports(as % of merchandise exports) in Korea (Republic) in 1971 to that in 1973?
Offer a very short reply. 1.2. What is the ratio of the Exports(as % of merchandise exports) of Pakistan in 1971 to that in 1973?
Ensure brevity in your answer.  2.84. What is the ratio of the Exports(as % of merchandise exports) in Middle East & North Africa (developing only) in 1971 to that in 1974?
Give a very brief answer. 0.88. What is the ratio of the Exports(as % of merchandise exports) of Italy in 1971 to that in 1974?
Offer a terse response. 0.98. What is the ratio of the Exports(as % of merchandise exports) in Korea (Republic) in 1971 to that in 1974?
Ensure brevity in your answer.  1.89. What is the ratio of the Exports(as % of merchandise exports) in Pakistan in 1971 to that in 1974?
Give a very brief answer. 2.51. What is the ratio of the Exports(as % of merchandise exports) in Middle East & North Africa (developing only) in 1971 to that in 1975?
Offer a terse response. 0.91. What is the ratio of the Exports(as % of merchandise exports) in Italy in 1971 to that in 1975?
Give a very brief answer. 1.19. What is the ratio of the Exports(as % of merchandise exports) of Korea (Republic) in 1971 to that in 1975?
Provide a succinct answer. 3.16. What is the ratio of the Exports(as % of merchandise exports) in Pakistan in 1971 to that in 1975?
Offer a very short reply. 1.57. What is the ratio of the Exports(as % of merchandise exports) of Middle East & North Africa (developing only) in 1971 to that in 1976?
Provide a short and direct response. 1.41. What is the ratio of the Exports(as % of merchandise exports) of Italy in 1971 to that in 1976?
Provide a short and direct response. 1.17. What is the ratio of the Exports(as % of merchandise exports) in Korea (Republic) in 1971 to that in 1976?
Provide a succinct answer. 3.4. What is the ratio of the Exports(as % of merchandise exports) of Pakistan in 1971 to that in 1976?
Your response must be concise. 3.77. What is the ratio of the Exports(as % of merchandise exports) of Middle East & North Africa (developing only) in 1971 to that in 1977?
Your answer should be very brief. 1.67. What is the ratio of the Exports(as % of merchandise exports) in Italy in 1971 to that in 1977?
Ensure brevity in your answer.  1.39. What is the ratio of the Exports(as % of merchandise exports) in Korea (Republic) in 1971 to that in 1977?
Provide a succinct answer. 2.6. What is the ratio of the Exports(as % of merchandise exports) in Pakistan in 1971 to that in 1977?
Offer a terse response. 4.85. What is the ratio of the Exports(as % of merchandise exports) in Middle East & North Africa (developing only) in 1972 to that in 1973?
Your answer should be very brief. 1.37. What is the ratio of the Exports(as % of merchandise exports) in Italy in 1972 to that in 1973?
Ensure brevity in your answer.  0.93. What is the ratio of the Exports(as % of merchandise exports) of Korea (Republic) in 1972 to that in 1973?
Provide a succinct answer. 1.12. What is the ratio of the Exports(as % of merchandise exports) of Pakistan in 1972 to that in 1973?
Ensure brevity in your answer.  2.62. What is the ratio of the Exports(as % of merchandise exports) of Middle East & North Africa (developing only) in 1972 to that in 1974?
Your answer should be very brief. 1.37. What is the ratio of the Exports(as % of merchandise exports) of Italy in 1972 to that in 1974?
Give a very brief answer. 0.97. What is the ratio of the Exports(as % of merchandise exports) in Korea (Republic) in 1972 to that in 1974?
Offer a terse response. 1.77. What is the ratio of the Exports(as % of merchandise exports) of Pakistan in 1972 to that in 1974?
Offer a terse response. 2.32. What is the ratio of the Exports(as % of merchandise exports) of Middle East & North Africa (developing only) in 1972 to that in 1975?
Your answer should be compact. 1.42. What is the ratio of the Exports(as % of merchandise exports) of Italy in 1972 to that in 1975?
Provide a short and direct response. 1.18. What is the ratio of the Exports(as % of merchandise exports) of Korea (Republic) in 1972 to that in 1975?
Your answer should be compact. 2.95. What is the ratio of the Exports(as % of merchandise exports) of Pakistan in 1972 to that in 1975?
Make the answer very short. 1.45. What is the ratio of the Exports(as % of merchandise exports) in Middle East & North Africa (developing only) in 1972 to that in 1976?
Offer a very short reply. 2.2. What is the ratio of the Exports(as % of merchandise exports) of Italy in 1972 to that in 1976?
Make the answer very short. 1.15. What is the ratio of the Exports(as % of merchandise exports) of Korea (Republic) in 1972 to that in 1976?
Ensure brevity in your answer.  3.17. What is the ratio of the Exports(as % of merchandise exports) of Pakistan in 1972 to that in 1976?
Give a very brief answer. 3.48. What is the ratio of the Exports(as % of merchandise exports) of Middle East & North Africa (developing only) in 1972 to that in 1977?
Offer a terse response. 2.6. What is the ratio of the Exports(as % of merchandise exports) in Italy in 1972 to that in 1977?
Offer a terse response. 1.38. What is the ratio of the Exports(as % of merchandise exports) in Korea (Republic) in 1972 to that in 1977?
Keep it short and to the point. 2.42. What is the ratio of the Exports(as % of merchandise exports) in Pakistan in 1972 to that in 1977?
Offer a very short reply. 4.48. What is the ratio of the Exports(as % of merchandise exports) in Italy in 1973 to that in 1974?
Keep it short and to the point. 1.05. What is the ratio of the Exports(as % of merchandise exports) of Korea (Republic) in 1973 to that in 1974?
Your answer should be compact. 1.57. What is the ratio of the Exports(as % of merchandise exports) in Pakistan in 1973 to that in 1974?
Make the answer very short. 0.88. What is the ratio of the Exports(as % of merchandise exports) in Middle East & North Africa (developing only) in 1973 to that in 1975?
Keep it short and to the point. 1.03. What is the ratio of the Exports(as % of merchandise exports) in Italy in 1973 to that in 1975?
Make the answer very short. 1.28. What is the ratio of the Exports(as % of merchandise exports) in Korea (Republic) in 1973 to that in 1975?
Your response must be concise. 2.63. What is the ratio of the Exports(as % of merchandise exports) of Pakistan in 1973 to that in 1975?
Ensure brevity in your answer.  0.55. What is the ratio of the Exports(as % of merchandise exports) of Middle East & North Africa (developing only) in 1973 to that in 1976?
Your response must be concise. 1.6. What is the ratio of the Exports(as % of merchandise exports) of Italy in 1973 to that in 1976?
Your response must be concise. 1.25. What is the ratio of the Exports(as % of merchandise exports) in Korea (Republic) in 1973 to that in 1976?
Your answer should be compact. 2.83. What is the ratio of the Exports(as % of merchandise exports) in Pakistan in 1973 to that in 1976?
Your answer should be compact. 1.33. What is the ratio of the Exports(as % of merchandise exports) in Middle East & North Africa (developing only) in 1973 to that in 1977?
Offer a very short reply. 1.9. What is the ratio of the Exports(as % of merchandise exports) of Italy in 1973 to that in 1977?
Ensure brevity in your answer.  1.49. What is the ratio of the Exports(as % of merchandise exports) in Korea (Republic) in 1973 to that in 1977?
Your answer should be very brief. 2.16. What is the ratio of the Exports(as % of merchandise exports) in Pakistan in 1973 to that in 1977?
Keep it short and to the point. 1.71. What is the ratio of the Exports(as % of merchandise exports) of Middle East & North Africa (developing only) in 1974 to that in 1975?
Ensure brevity in your answer.  1.04. What is the ratio of the Exports(as % of merchandise exports) in Italy in 1974 to that in 1975?
Ensure brevity in your answer.  1.22. What is the ratio of the Exports(as % of merchandise exports) in Korea (Republic) in 1974 to that in 1975?
Ensure brevity in your answer.  1.67. What is the ratio of the Exports(as % of merchandise exports) of Pakistan in 1974 to that in 1975?
Ensure brevity in your answer.  0.63. What is the ratio of the Exports(as % of merchandise exports) in Middle East & North Africa (developing only) in 1974 to that in 1976?
Offer a very short reply. 1.61. What is the ratio of the Exports(as % of merchandise exports) in Italy in 1974 to that in 1976?
Give a very brief answer. 1.19. What is the ratio of the Exports(as % of merchandise exports) of Korea (Republic) in 1974 to that in 1976?
Offer a terse response. 1.8. What is the ratio of the Exports(as % of merchandise exports) of Pakistan in 1974 to that in 1976?
Your answer should be compact. 1.5. What is the ratio of the Exports(as % of merchandise exports) in Middle East & North Africa (developing only) in 1974 to that in 1977?
Ensure brevity in your answer.  1.91. What is the ratio of the Exports(as % of merchandise exports) of Italy in 1974 to that in 1977?
Your answer should be compact. 1.42. What is the ratio of the Exports(as % of merchandise exports) in Korea (Republic) in 1974 to that in 1977?
Make the answer very short. 1.37. What is the ratio of the Exports(as % of merchandise exports) of Pakistan in 1974 to that in 1977?
Keep it short and to the point. 1.93. What is the ratio of the Exports(as % of merchandise exports) of Middle East & North Africa (developing only) in 1975 to that in 1976?
Your response must be concise. 1.55. What is the ratio of the Exports(as % of merchandise exports) of Korea (Republic) in 1975 to that in 1976?
Give a very brief answer. 1.08. What is the ratio of the Exports(as % of merchandise exports) of Pakistan in 1975 to that in 1976?
Give a very brief answer. 2.4. What is the ratio of the Exports(as % of merchandise exports) of Middle East & North Africa (developing only) in 1975 to that in 1977?
Provide a succinct answer. 1.83. What is the ratio of the Exports(as % of merchandise exports) of Italy in 1975 to that in 1977?
Offer a very short reply. 1.17. What is the ratio of the Exports(as % of merchandise exports) of Korea (Republic) in 1975 to that in 1977?
Offer a terse response. 0.82. What is the ratio of the Exports(as % of merchandise exports) of Pakistan in 1975 to that in 1977?
Give a very brief answer. 3.09. What is the ratio of the Exports(as % of merchandise exports) of Middle East & North Africa (developing only) in 1976 to that in 1977?
Ensure brevity in your answer.  1.18. What is the ratio of the Exports(as % of merchandise exports) in Italy in 1976 to that in 1977?
Your response must be concise. 1.2. What is the ratio of the Exports(as % of merchandise exports) in Korea (Republic) in 1976 to that in 1977?
Your answer should be compact. 0.76. What is the ratio of the Exports(as % of merchandise exports) in Pakistan in 1976 to that in 1977?
Provide a short and direct response. 1.29. What is the difference between the highest and the second highest Exports(as % of merchandise exports) of Middle East & North Africa (developing only)?
Give a very brief answer. 2.48. What is the difference between the highest and the second highest Exports(as % of merchandise exports) of Italy?
Your response must be concise. 0.07. What is the difference between the highest and the second highest Exports(as % of merchandise exports) of Korea (Republic)?
Offer a terse response. 0.39. What is the difference between the highest and the second highest Exports(as % of merchandise exports) in Pakistan?
Provide a succinct answer. 2.26. What is the difference between the highest and the lowest Exports(as % of merchandise exports) in Middle East & North Africa (developing only)?
Make the answer very short. 5.71. What is the difference between the highest and the lowest Exports(as % of merchandise exports) of Italy?
Make the answer very short. 0.53. What is the difference between the highest and the lowest Exports(as % of merchandise exports) in Korea (Republic)?
Make the answer very short. 4.07. What is the difference between the highest and the lowest Exports(as % of merchandise exports) in Pakistan?
Provide a succinct answer. 23.38. 